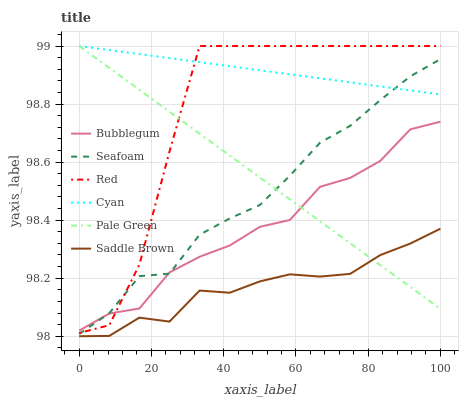Does Saddle Brown have the minimum area under the curve?
Answer yes or no. Yes. Does Cyan have the maximum area under the curve?
Answer yes or no. Yes. Does Bubblegum have the minimum area under the curve?
Answer yes or no. No. Does Bubblegum have the maximum area under the curve?
Answer yes or no. No. Is Pale Green the smoothest?
Answer yes or no. Yes. Is Red the roughest?
Answer yes or no. Yes. Is Bubblegum the smoothest?
Answer yes or no. No. Is Bubblegum the roughest?
Answer yes or no. No. Does Saddle Brown have the lowest value?
Answer yes or no. Yes. Does Bubblegum have the lowest value?
Answer yes or no. No. Does Red have the highest value?
Answer yes or no. Yes. Does Bubblegum have the highest value?
Answer yes or no. No. Is Saddle Brown less than Red?
Answer yes or no. Yes. Is Cyan greater than Bubblegum?
Answer yes or no. Yes. Does Seafoam intersect Pale Green?
Answer yes or no. Yes. Is Seafoam less than Pale Green?
Answer yes or no. No. Is Seafoam greater than Pale Green?
Answer yes or no. No. Does Saddle Brown intersect Red?
Answer yes or no. No. 